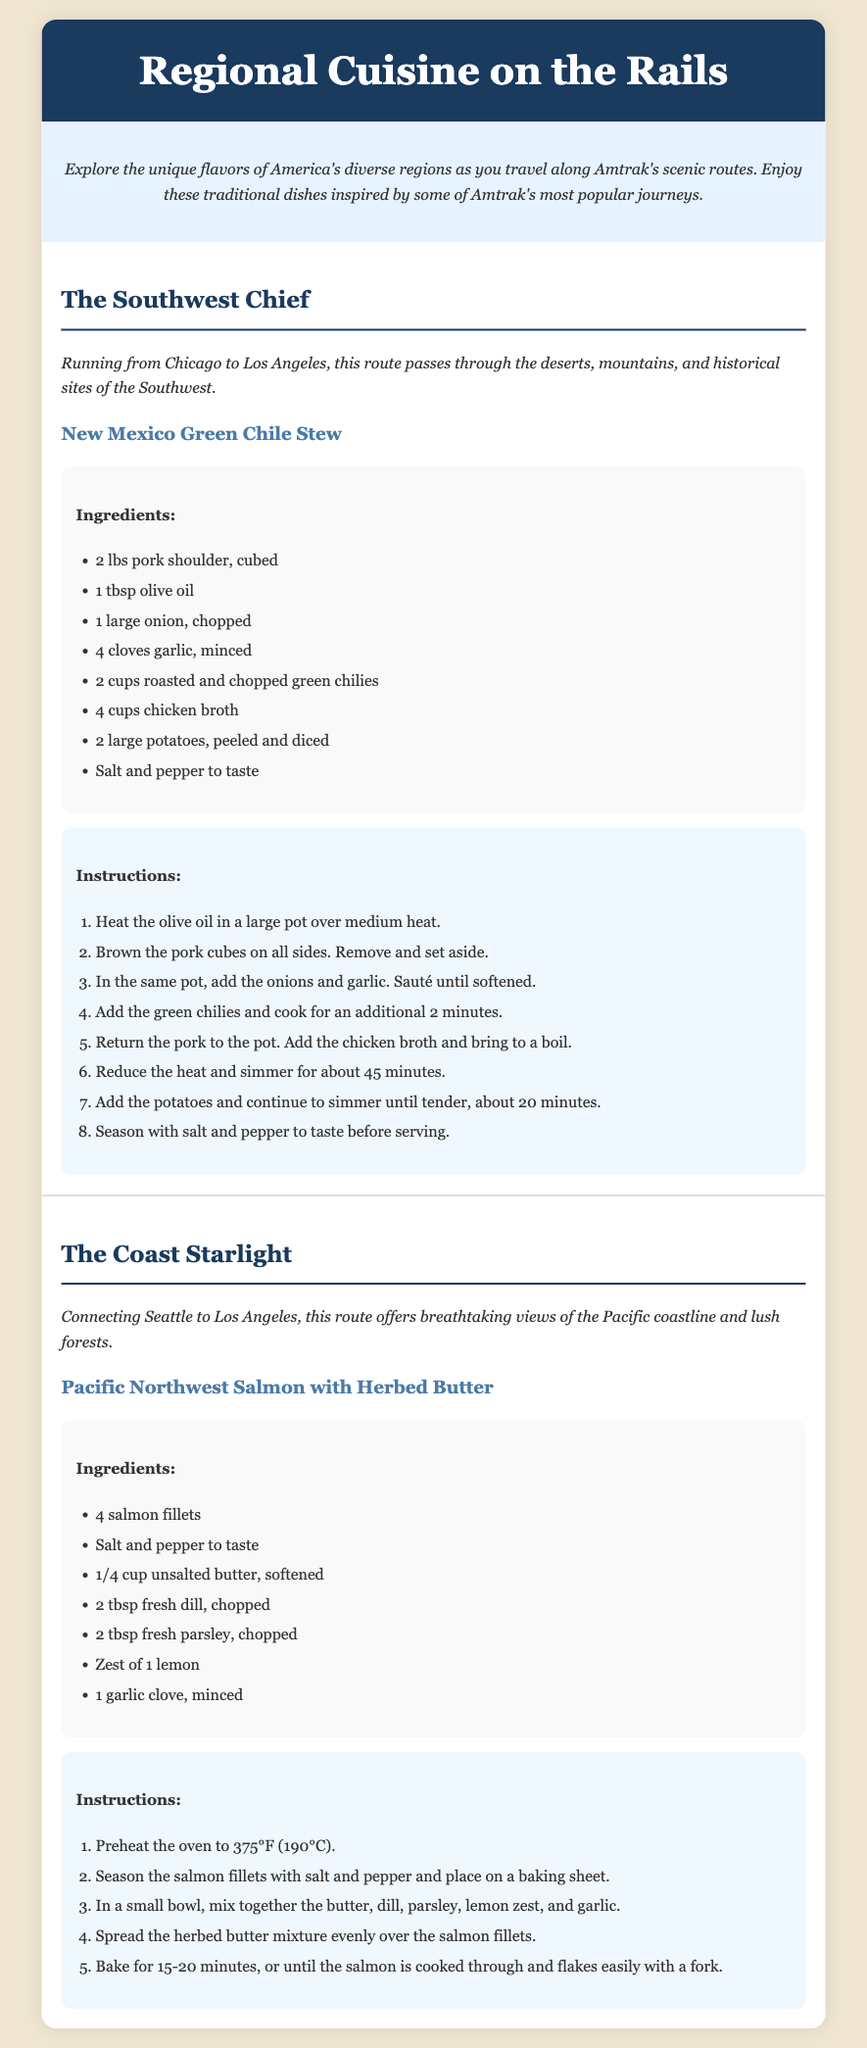What dish is featured for The Southwest Chief? The Southwest Chief features New Mexico Green Chile Stew, which is mentioned as the traditional dish for that route.
Answer: New Mexico Green Chile Stew How many ingredients are listed for the Pacific Northwest Salmon with Herbed Butter? The recipe lists a total of 7 ingredients in the ingredients section for Pacific Northwest Salmon with Herbed Butter.
Answer: 7 What is the cooking time for salmon according to the recipe? The cooking time specified for the salmon is 15-20 minutes, which can be found in the instructions section of the recipe.
Answer: 15-20 minutes What type of meat is used in New Mexico Green Chile Stew? The recipe for New Mexico Green Chile Stew specifies pork shoulder as the type of meat used.
Answer: Pork shoulder Which route connects Seattle to Los Angeles? The document specifies that The Coast Starlight is the route connecting Seattle to Los Angeles.
Answer: The Coast Starlight 